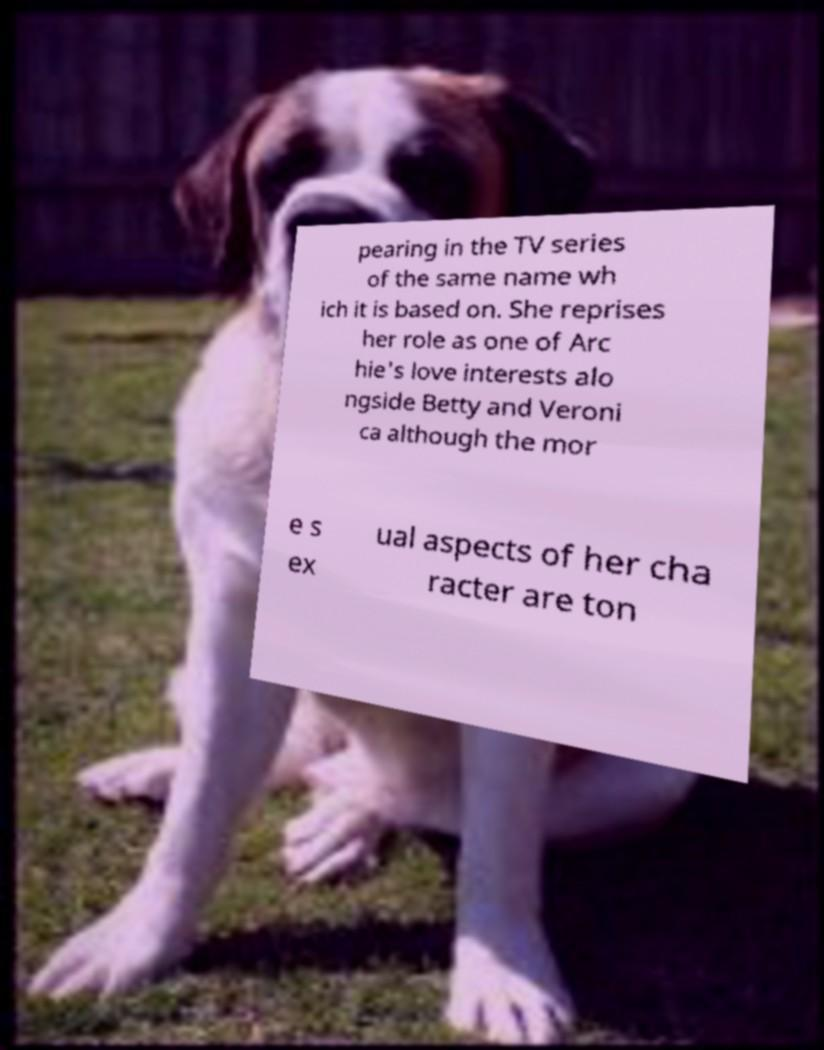Could you assist in decoding the text presented in this image and type it out clearly? pearing in the TV series of the same name wh ich it is based on. She reprises her role as one of Arc hie's love interests alo ngside Betty and Veroni ca although the mor e s ex ual aspects of her cha racter are ton 